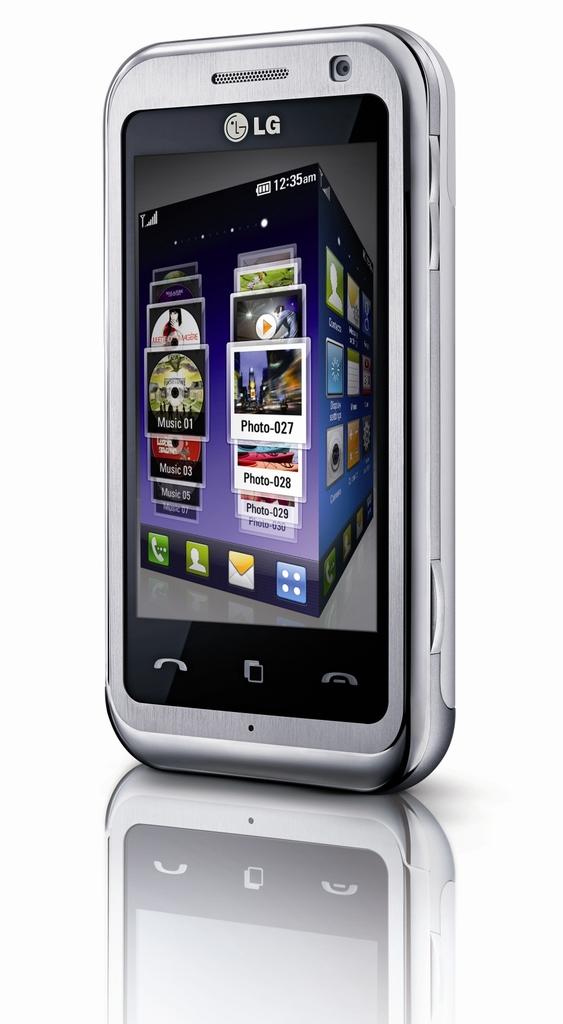Who is the maker of the phone?
Your response must be concise. Lg. What time is it, according to the phone?
Ensure brevity in your answer.  12:35 am. 